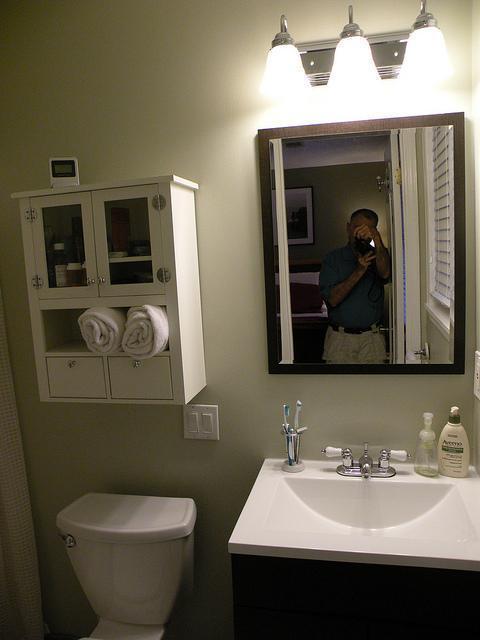How many light bulbs need to be replaced?
Give a very brief answer. 0. How many toothbrushes are on the counter?
Give a very brief answer. 2. 